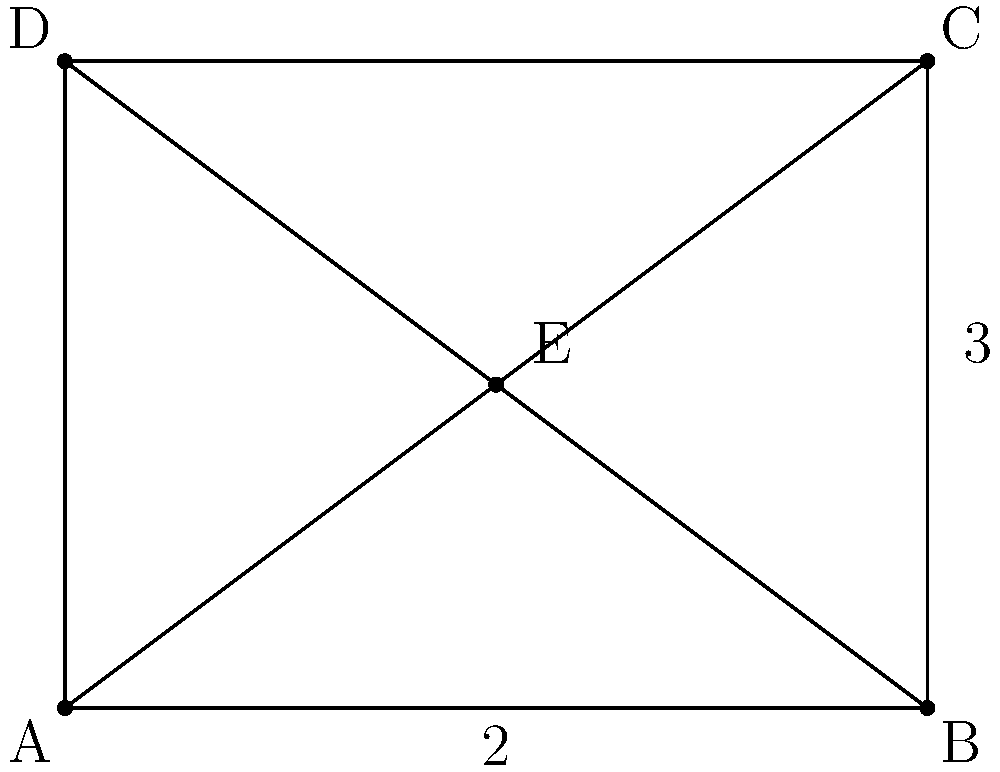In an abstract painting inspired by a book character, you decide to represent the character as a rectangle with diagonals. If the rectangle has a width of 4 units and a height of 3 units, and point E is the intersection of the diagonals, what is the ratio of the area of triangle AEB to the area of the entire rectangle? Let's approach this step-by-step:

1) The area of the rectangle is easy to calculate:
   $A_{rectangle} = width \times height = 4 \times 3 = 12$ square units

2) To find the area of triangle AEB, we need to know its base and height.
   The base is the width of the rectangle, which is 4 units.

3) The height of the triangle is the distance from point E to side AB.
   Point E is at the intersection of the diagonals, which is the center of the rectangle.

4) In a rectangle, the center divides each side in a 1:1 ratio.
   So, the height of triangle AEB is half the height of the rectangle:
   $h_{AEB} = \frac{1}{2} \times 3 = 1.5$ units

5) Now we can calculate the area of triangle AEB:
   $A_{AEB} = \frac{1}{2} \times base \times height = \frac{1}{2} \times 4 \times 1.5 = 3$ square units

6) The ratio of the areas is:
   $\frac{A_{AEB}}{A_{rectangle}} = \frac{3}{12} = \frac{1}{4}$

Therefore, the area of triangle AEB is $\frac{1}{4}$ or 25% of the area of the rectangle.
Answer: $\frac{1}{4}$ 